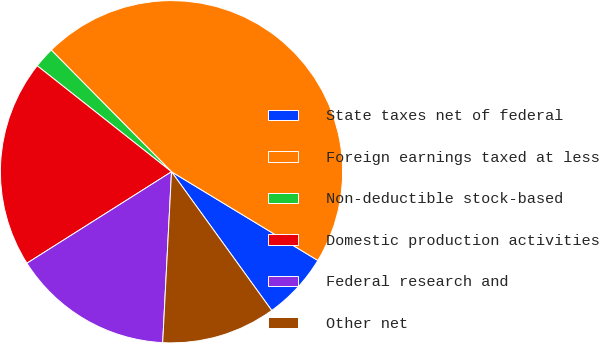<chart> <loc_0><loc_0><loc_500><loc_500><pie_chart><fcel>State taxes net of federal<fcel>Foreign earnings taxed at less<fcel>Non-deductible stock-based<fcel>Domestic production activities<fcel>Federal research and<fcel>Other net<nl><fcel>6.37%<fcel>46.08%<fcel>1.96%<fcel>19.61%<fcel>15.2%<fcel>10.78%<nl></chart> 